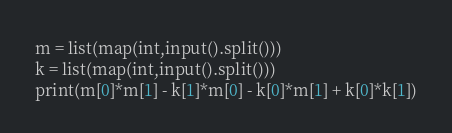<code> <loc_0><loc_0><loc_500><loc_500><_Python_>m = list(map(int,input().split()))
k = list(map(int,input().split()))
print(m[0]*m[1] - k[1]*m[0] - k[0]*m[1] + k[0]*k[1])
</code> 